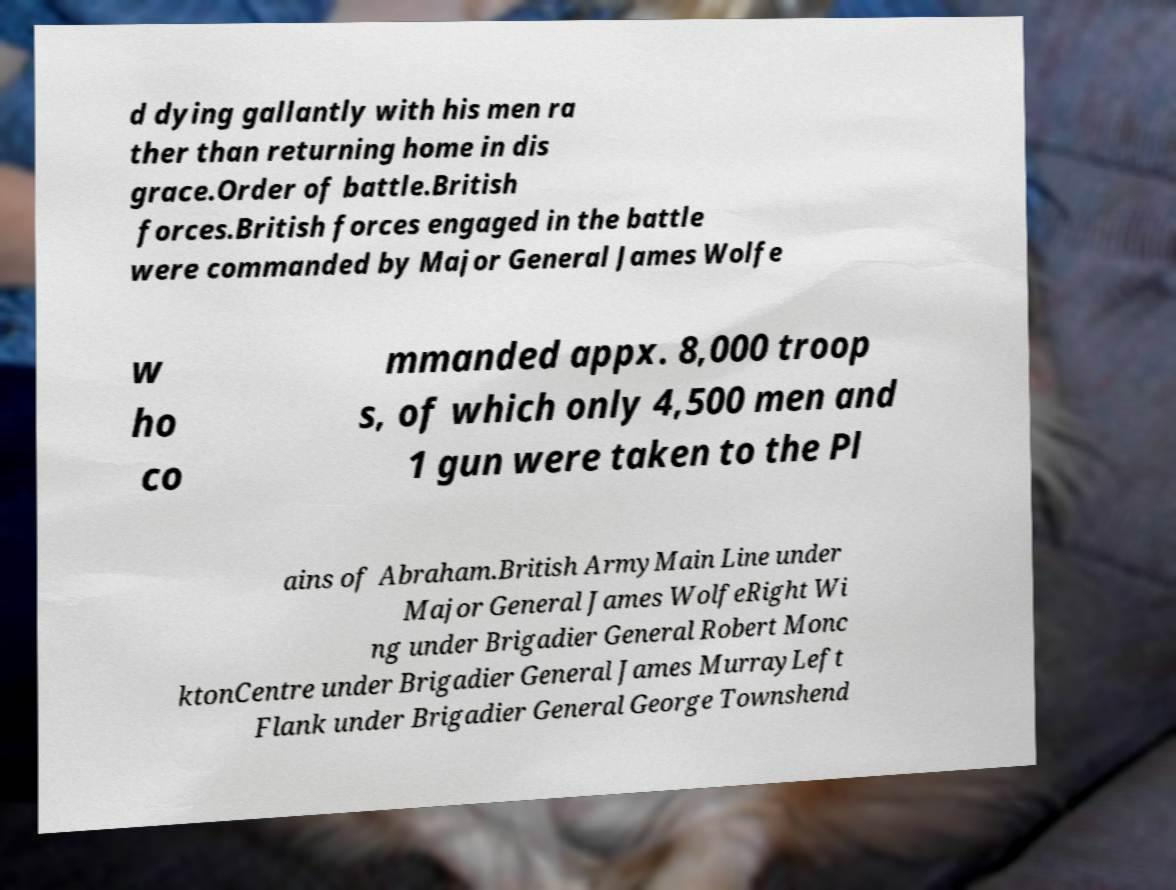I need the written content from this picture converted into text. Can you do that? d dying gallantly with his men ra ther than returning home in dis grace.Order of battle.British forces.British forces engaged in the battle were commanded by Major General James Wolfe w ho co mmanded appx. 8,000 troop s, of which only 4,500 men and 1 gun were taken to the Pl ains of Abraham.British ArmyMain Line under Major General James WolfeRight Wi ng under Brigadier General Robert Monc ktonCentre under Brigadier General James MurrayLeft Flank under Brigadier General George Townshend 